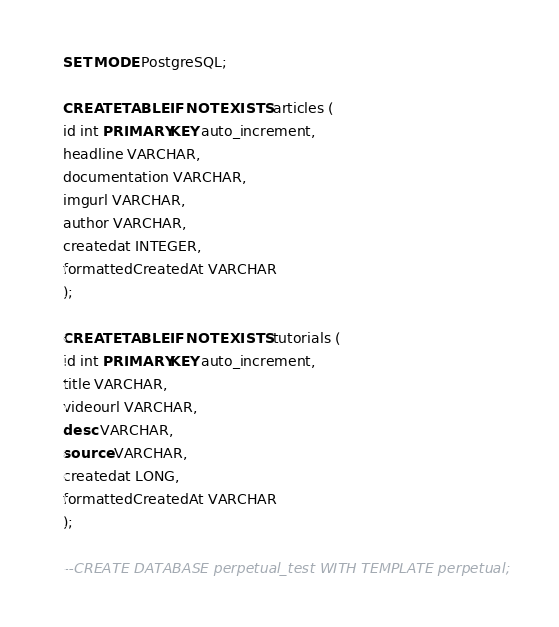<code> <loc_0><loc_0><loc_500><loc_500><_SQL_>SET MODE PostgreSQL;

CREATE TABLE IF NOT EXISTS articles (
id int PRIMARY KEY auto_increment,
headline VARCHAR,
documentation VARCHAR,
imgurl VARCHAR,
author VARCHAR,
createdat INTEGER,
formattedCreatedAt VARCHAR
);

CREATE TABLE IF NOT EXISTS tutorials (
id int PRIMARY KEY auto_increment,
title VARCHAR,
videourl VARCHAR,
desc VARCHAR,
source VARCHAR,
createdat LONG,
formattedCreatedAt VARCHAR
);

--CREATE DATABASE perpetual_test WITH TEMPLATE perpetual;</code> 